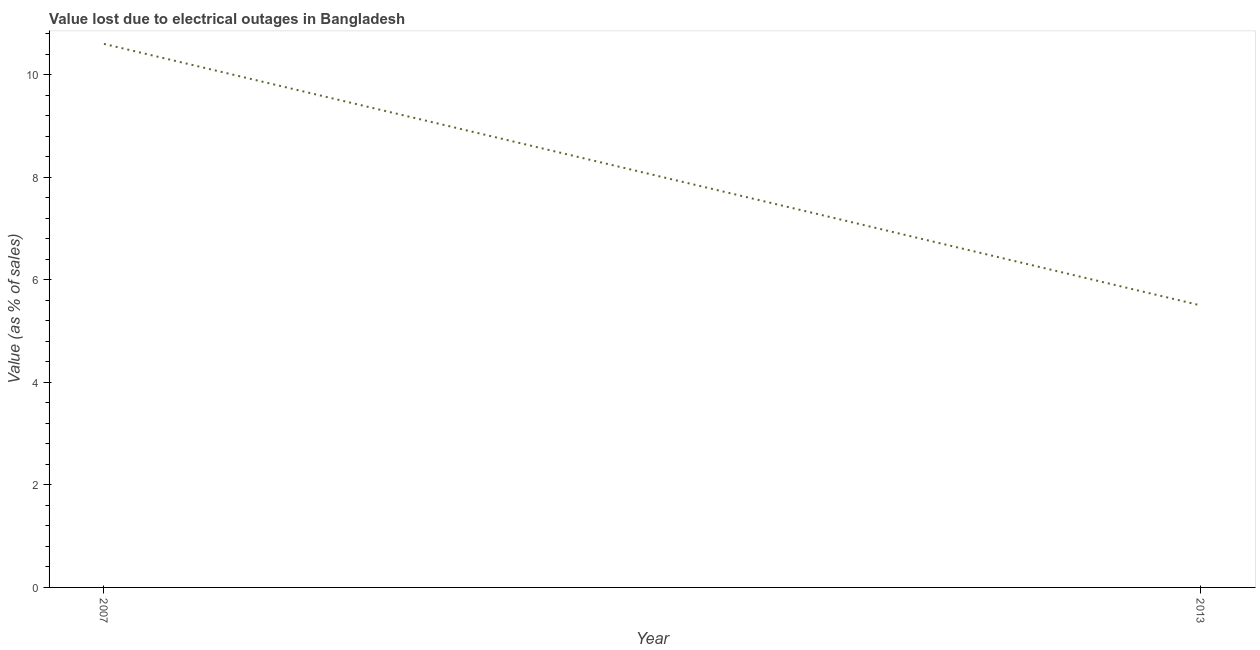What is the value lost due to electrical outages in 2013?
Offer a very short reply. 5.5. Across all years, what is the maximum value lost due to electrical outages?
Provide a succinct answer. 10.6. Across all years, what is the minimum value lost due to electrical outages?
Provide a short and direct response. 5.5. In which year was the value lost due to electrical outages maximum?
Keep it short and to the point. 2007. What is the sum of the value lost due to electrical outages?
Your answer should be very brief. 16.1. What is the difference between the value lost due to electrical outages in 2007 and 2013?
Your response must be concise. 5.1. What is the average value lost due to electrical outages per year?
Provide a succinct answer. 8.05. What is the median value lost due to electrical outages?
Give a very brief answer. 8.05. In how many years, is the value lost due to electrical outages greater than 2.4 %?
Give a very brief answer. 2. Do a majority of the years between 2013 and 2007 (inclusive) have value lost due to electrical outages greater than 0.8 %?
Keep it short and to the point. No. What is the ratio of the value lost due to electrical outages in 2007 to that in 2013?
Ensure brevity in your answer.  1.93. In how many years, is the value lost due to electrical outages greater than the average value lost due to electrical outages taken over all years?
Provide a short and direct response. 1. Are the values on the major ticks of Y-axis written in scientific E-notation?
Provide a succinct answer. No. What is the title of the graph?
Your answer should be very brief. Value lost due to electrical outages in Bangladesh. What is the label or title of the Y-axis?
Your answer should be compact. Value (as % of sales). What is the Value (as % of sales) in 2007?
Ensure brevity in your answer.  10.6. What is the difference between the Value (as % of sales) in 2007 and 2013?
Offer a terse response. 5.1. What is the ratio of the Value (as % of sales) in 2007 to that in 2013?
Offer a terse response. 1.93. 